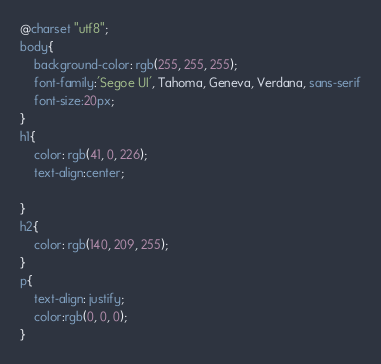Convert code to text. <code><loc_0><loc_0><loc_500><loc_500><_CSS_>@charset "utf8";
body{
    background-color: rgb(255, 255, 255);
    font-family:'Segoe UI', Tahoma, Geneva, Verdana, sans-serif
    font-size:20px;
}
h1{
    color: rgb(41, 0, 226);
    text-align:center;
    
}
h2{
    color: rgb(140, 209, 255);
}
p{
    text-align: justify;
    color:rgb(0, 0, 0);
}</code> 